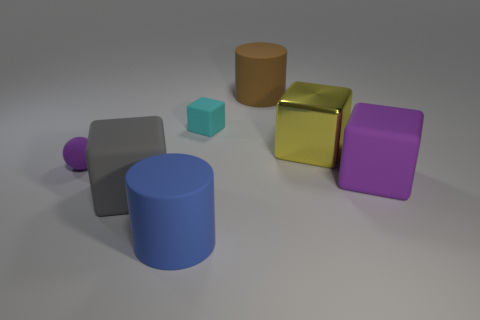Add 1 big gray cubes. How many objects exist? 8 Subtract all balls. How many objects are left? 6 Add 2 tiny rubber objects. How many tiny rubber objects are left? 4 Add 4 purple matte cubes. How many purple matte cubes exist? 5 Subtract 0 red blocks. How many objects are left? 7 Subtract all big purple rubber blocks. Subtract all small cyan rubber things. How many objects are left? 5 